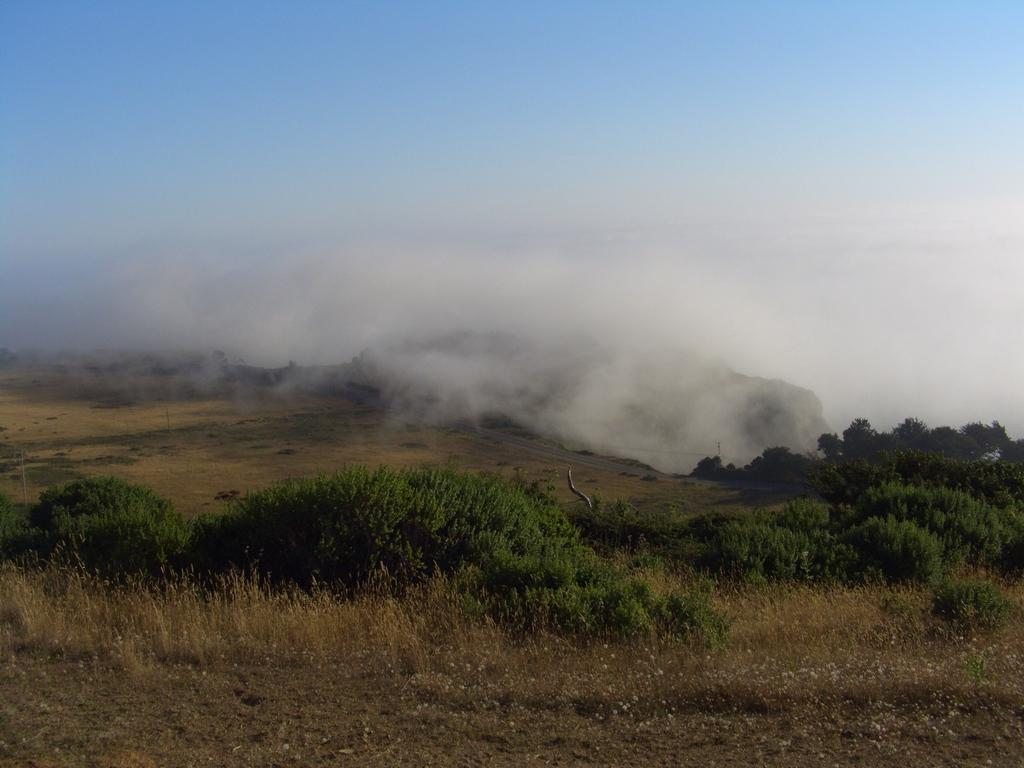What type of surface is visible in the image? There is a grass surface in the image. What type of plants can be seen on the grass surface? There are grass plants and other plants visible in the image. What is the weather condition in the image? There is fog visible in the image, which suggests a misty or foggy condition. What can be seen in the background of the image? There is a sky visible in the background of the image. Can you see an aunt pushing a swing in the image? There is no swing or aunt present in the image. How many sheep are visible in the image? There are no sheep present in the image. 